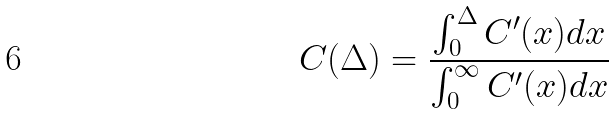<formula> <loc_0><loc_0><loc_500><loc_500>C ( \Delta ) = \frac { \int _ { 0 } ^ { \Delta } C ^ { \prime } ( x ) d x } { \int _ { 0 } ^ { \infty } C ^ { \prime } ( x ) d x }</formula> 